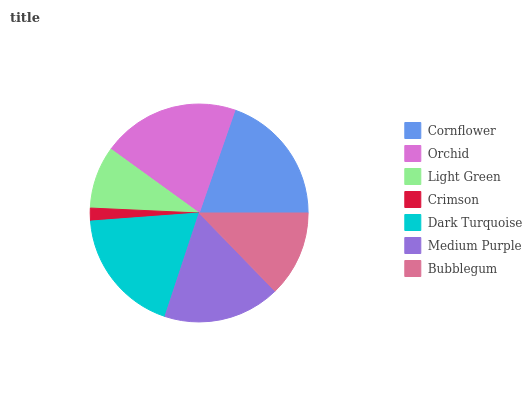Is Crimson the minimum?
Answer yes or no. Yes. Is Orchid the maximum?
Answer yes or no. Yes. Is Light Green the minimum?
Answer yes or no. No. Is Light Green the maximum?
Answer yes or no. No. Is Orchid greater than Light Green?
Answer yes or no. Yes. Is Light Green less than Orchid?
Answer yes or no. Yes. Is Light Green greater than Orchid?
Answer yes or no. No. Is Orchid less than Light Green?
Answer yes or no. No. Is Medium Purple the high median?
Answer yes or no. Yes. Is Medium Purple the low median?
Answer yes or no. Yes. Is Bubblegum the high median?
Answer yes or no. No. Is Dark Turquoise the low median?
Answer yes or no. No. 